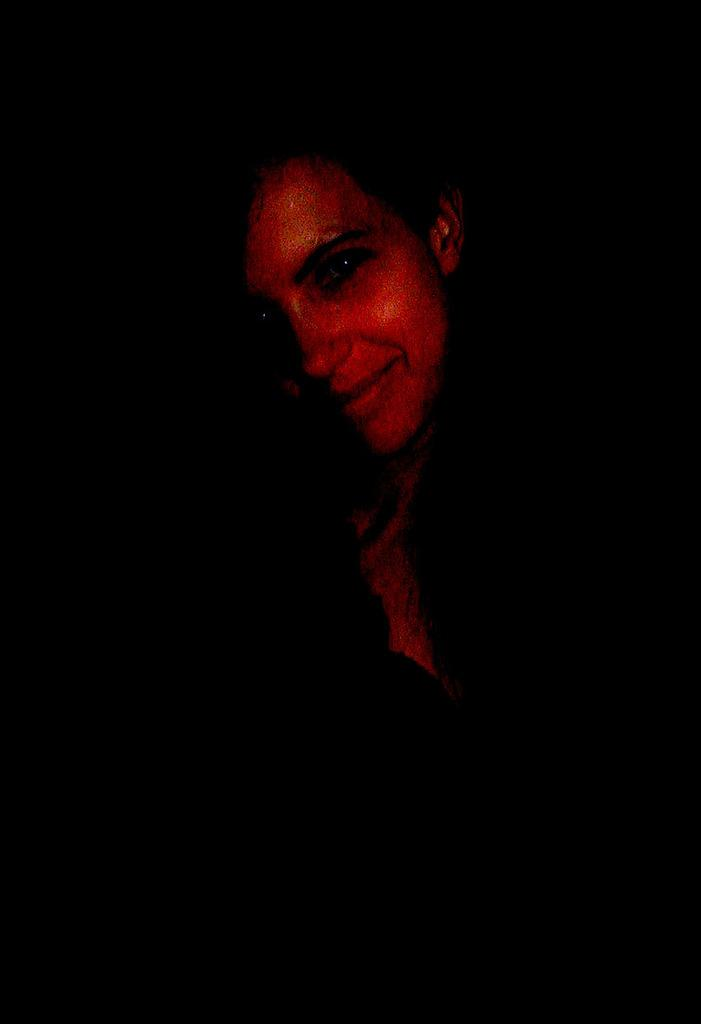Who is present in the image? There is a woman in the image. What expression does the woman have? The woman is smiling. How much money is the woman holding in the image? There is no indication of money in the image; it only shows a woman smiling. 